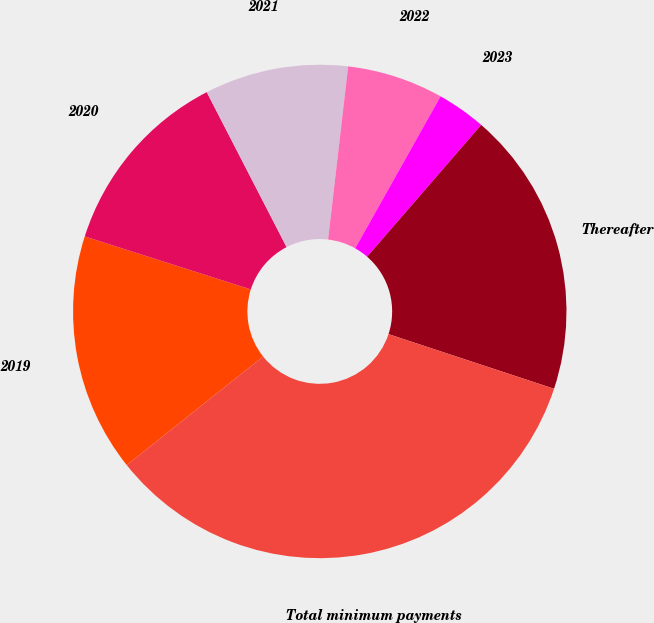<chart> <loc_0><loc_0><loc_500><loc_500><pie_chart><fcel>2019<fcel>2020<fcel>2021<fcel>2022<fcel>2023<fcel>Thereafter<fcel>Total minimum payments<nl><fcel>15.62%<fcel>12.51%<fcel>9.41%<fcel>6.31%<fcel>3.21%<fcel>18.72%<fcel>34.23%<nl></chart> 